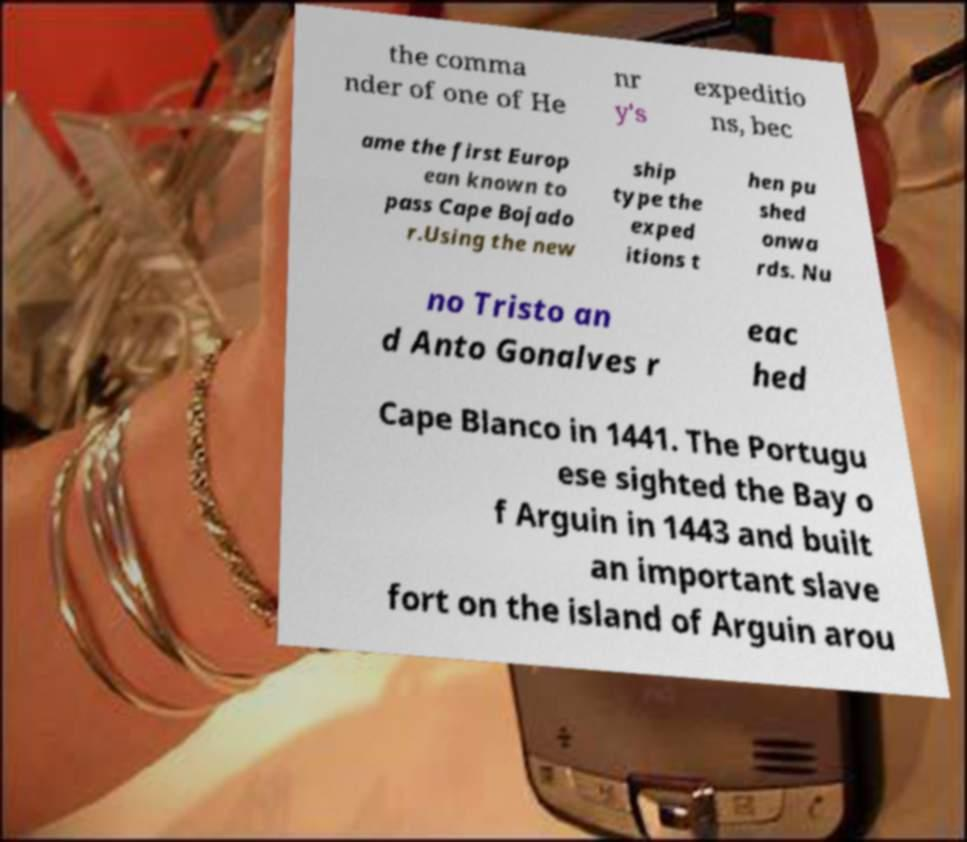What messages or text are displayed in this image? I need them in a readable, typed format. the comma nder of one of He nr y's expeditio ns, bec ame the first Europ ean known to pass Cape Bojado r.Using the new ship type the exped itions t hen pu shed onwa rds. Nu no Tristo an d Anto Gonalves r eac hed Cape Blanco in 1441. The Portugu ese sighted the Bay o f Arguin in 1443 and built an important slave fort on the island of Arguin arou 